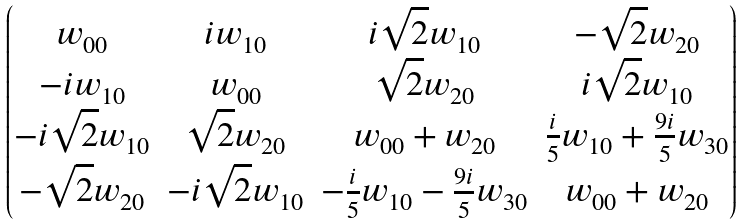<formula> <loc_0><loc_0><loc_500><loc_500>\begin{pmatrix} w _ { 0 0 } & i w _ { 1 0 } & i \sqrt { 2 } w _ { 1 0 } & - \sqrt { 2 } w _ { 2 0 } \\ - i w _ { 1 0 } & w _ { 0 0 } & \sqrt { 2 } w _ { 2 0 } & i \sqrt { 2 } w _ { 1 0 } \\ - i \sqrt { 2 } w _ { 1 0 } & \sqrt { 2 } w _ { 2 0 } & w _ { 0 0 } + w _ { 2 0 } & \frac { i } { 5 } w _ { 1 0 } + \frac { 9 i } { 5 } w _ { 3 0 } \\ - \sqrt { 2 } w _ { 2 0 } & - i \sqrt { 2 } w _ { 1 0 } & - \frac { i } { 5 } w _ { 1 0 } - \frac { 9 i } { 5 } w _ { 3 0 } & w _ { 0 0 } + w _ { 2 0 } \end{pmatrix}</formula> 